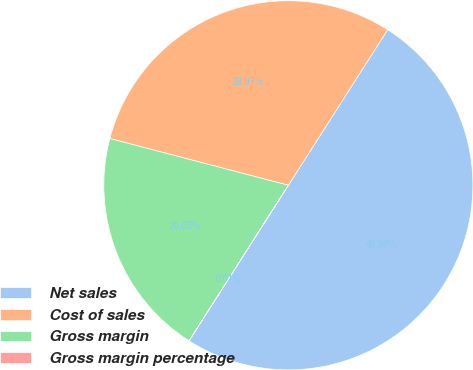<chart> <loc_0><loc_0><loc_500><loc_500><pie_chart><fcel>Net sales<fcel>Cost of sales<fcel>Gross margin<fcel>Gross margin percentage<nl><fcel>50.0%<fcel>29.97%<fcel>20.03%<fcel>0.01%<nl></chart> 